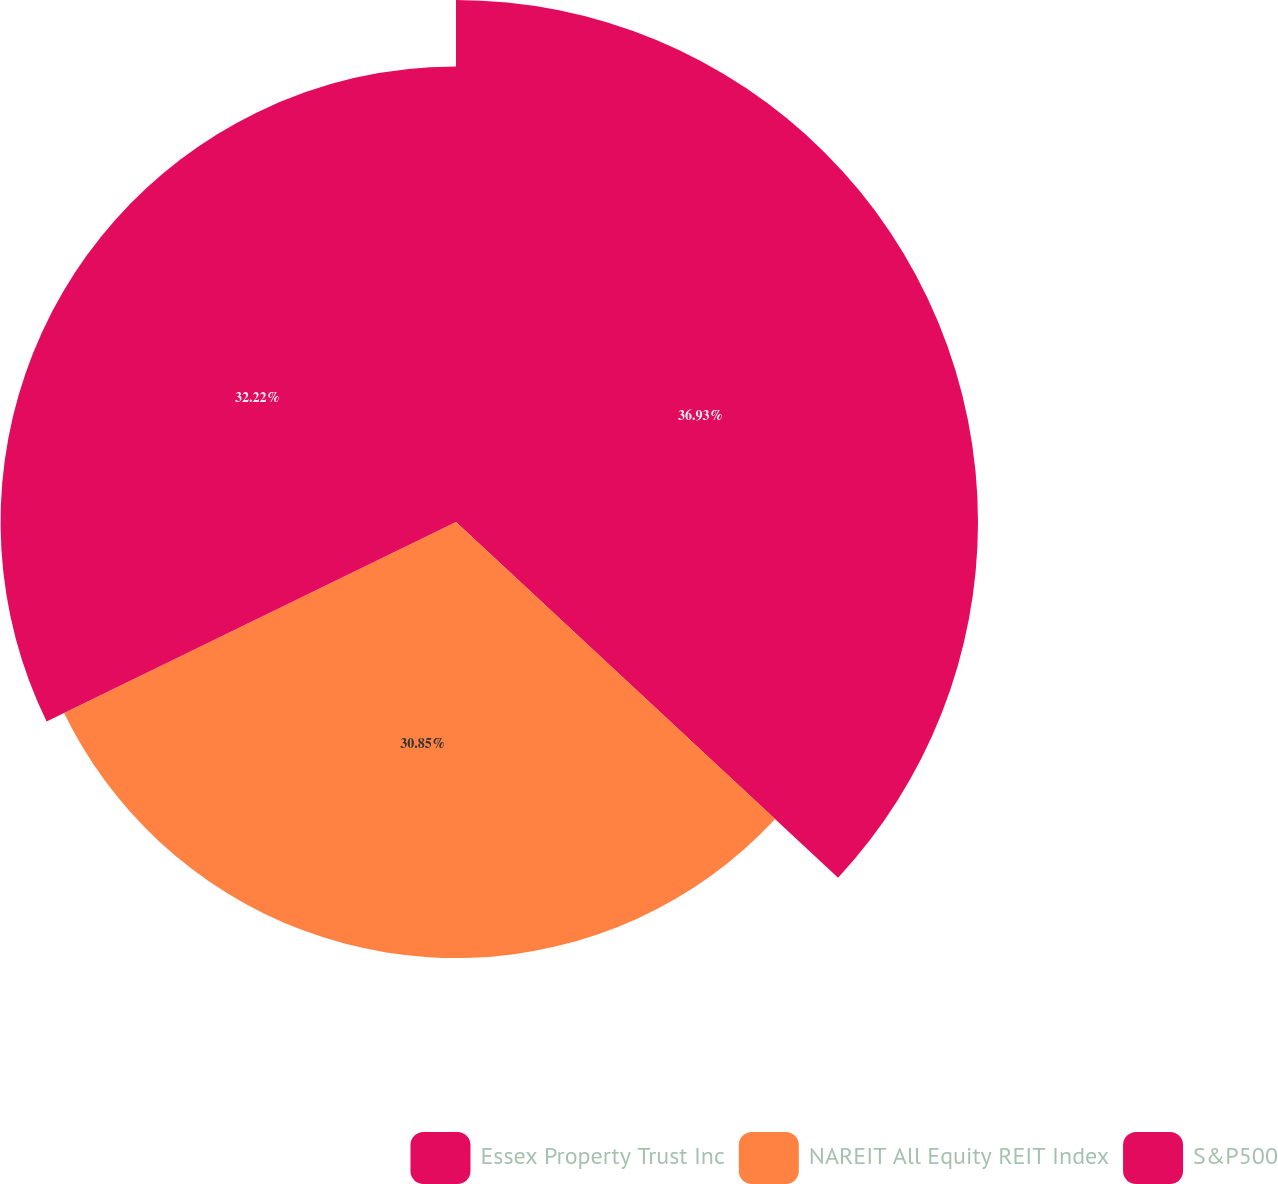Convert chart. <chart><loc_0><loc_0><loc_500><loc_500><pie_chart><fcel>Essex Property Trust Inc<fcel>NAREIT All Equity REIT Index<fcel>S&P500<nl><fcel>36.93%<fcel>30.85%<fcel>32.22%<nl></chart> 